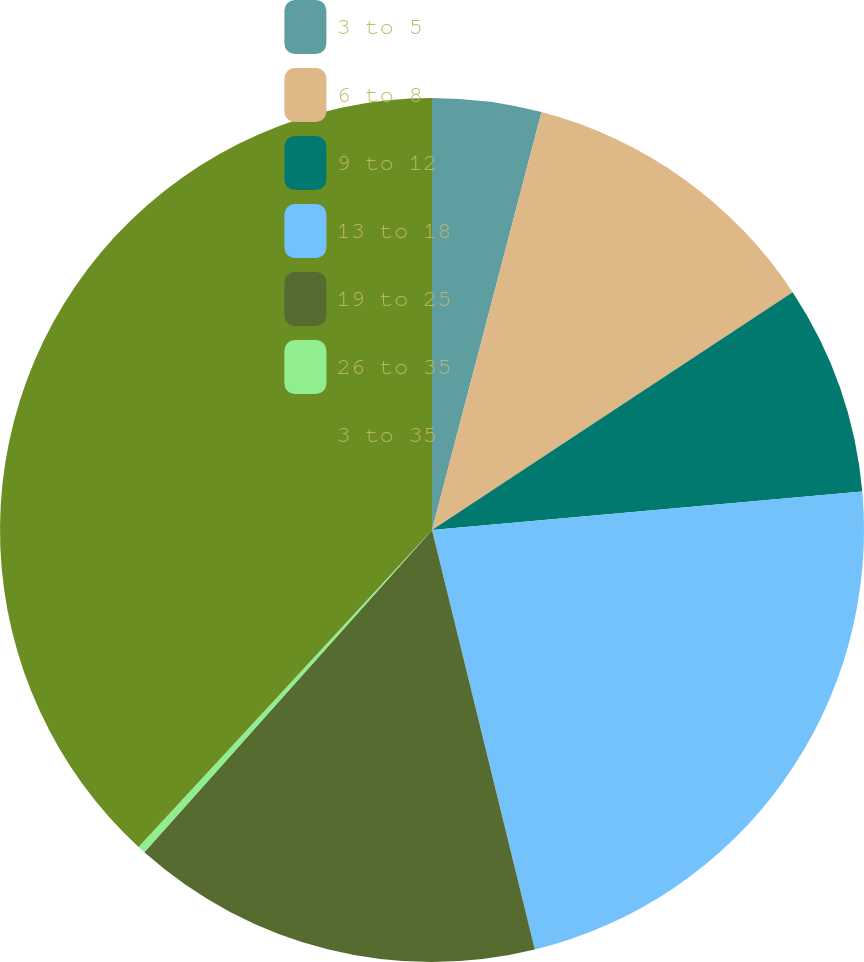<chart> <loc_0><loc_0><loc_500><loc_500><pie_chart><fcel>3 to 5<fcel>6 to 8<fcel>9 to 12<fcel>13 to 18<fcel>19 to 25<fcel>26 to 35<fcel>3 to 35<nl><fcel>4.08%<fcel>11.64%<fcel>7.86%<fcel>22.59%<fcel>15.42%<fcel>0.29%<fcel>38.11%<nl></chart> 